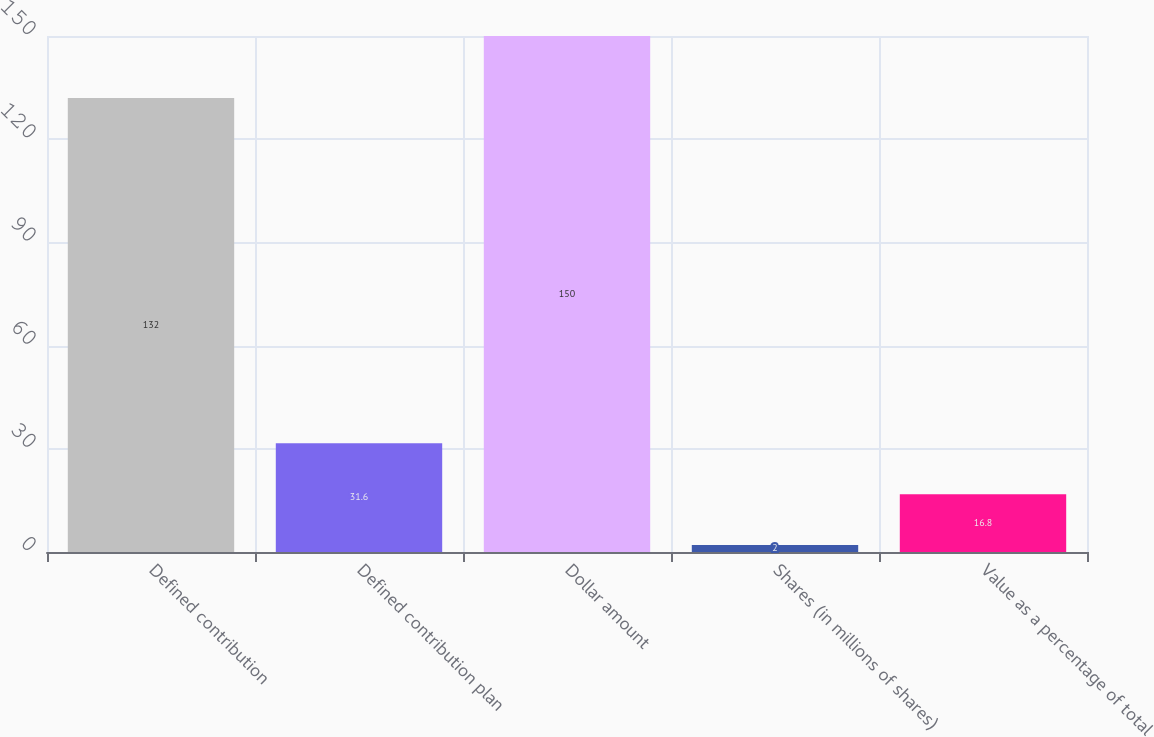Convert chart to OTSL. <chart><loc_0><loc_0><loc_500><loc_500><bar_chart><fcel>Defined contribution<fcel>Defined contribution plan<fcel>Dollar amount<fcel>Shares (in millions of shares)<fcel>Value as a percentage of total<nl><fcel>132<fcel>31.6<fcel>150<fcel>2<fcel>16.8<nl></chart> 